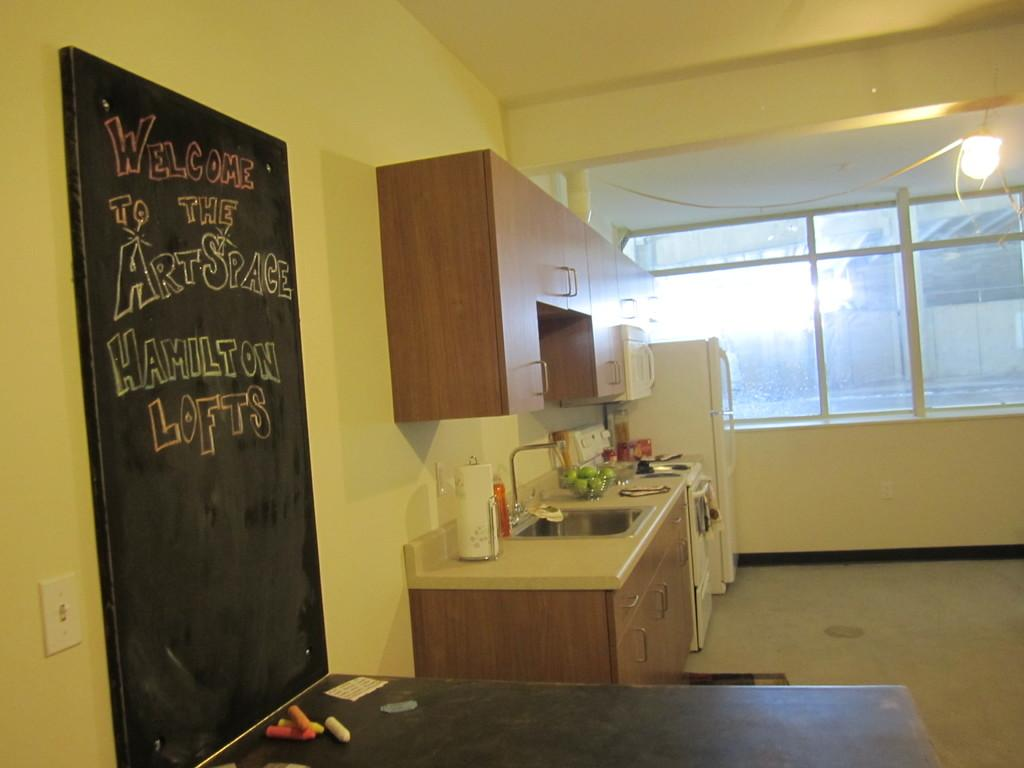<image>
Write a terse but informative summary of the picture. Room with a blackboard that says "Welcome to the art space". 